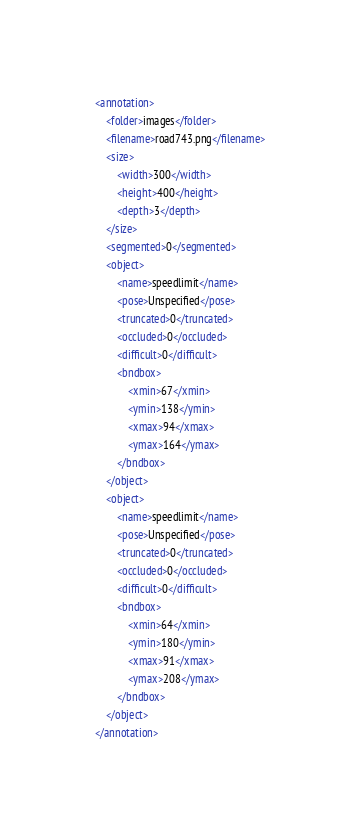Convert code to text. <code><loc_0><loc_0><loc_500><loc_500><_XML_>
<annotation>
    <folder>images</folder>
    <filename>road743.png</filename>
    <size>
        <width>300</width>
        <height>400</height>
        <depth>3</depth>
    </size>
    <segmented>0</segmented>
    <object>
        <name>speedlimit</name>
        <pose>Unspecified</pose>
        <truncated>0</truncated>
        <occluded>0</occluded>
        <difficult>0</difficult>
        <bndbox>
            <xmin>67</xmin>
            <ymin>138</ymin>
            <xmax>94</xmax>
            <ymax>164</ymax>
        </bndbox>
    </object>
    <object>
        <name>speedlimit</name>
        <pose>Unspecified</pose>
        <truncated>0</truncated>
        <occluded>0</occluded>
        <difficult>0</difficult>
        <bndbox>
            <xmin>64</xmin>
            <ymin>180</ymin>
            <xmax>91</xmax>
            <ymax>208</ymax>
        </bndbox>
    </object>
</annotation></code> 